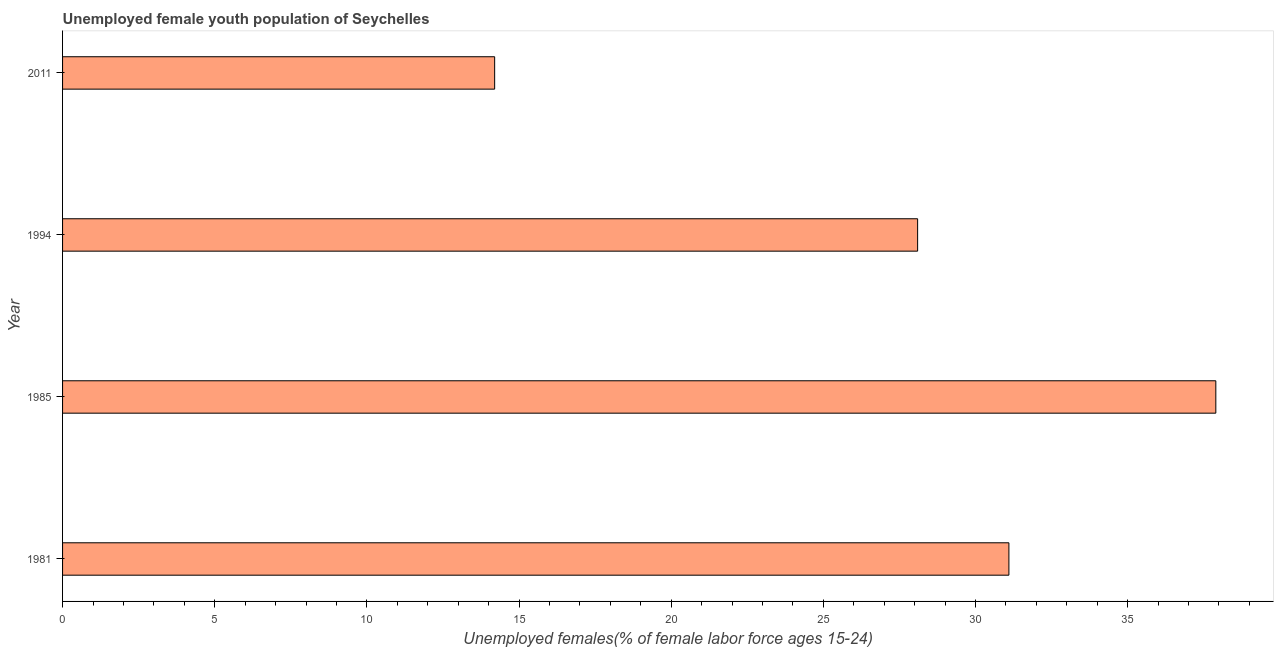Does the graph contain grids?
Offer a terse response. No. What is the title of the graph?
Make the answer very short. Unemployed female youth population of Seychelles. What is the label or title of the X-axis?
Offer a terse response. Unemployed females(% of female labor force ages 15-24). What is the label or title of the Y-axis?
Provide a succinct answer. Year. What is the unemployed female youth in 1985?
Give a very brief answer. 37.9. Across all years, what is the maximum unemployed female youth?
Make the answer very short. 37.9. Across all years, what is the minimum unemployed female youth?
Keep it short and to the point. 14.2. In which year was the unemployed female youth maximum?
Your answer should be compact. 1985. What is the sum of the unemployed female youth?
Your answer should be compact. 111.3. What is the difference between the unemployed female youth in 1994 and 2011?
Keep it short and to the point. 13.9. What is the average unemployed female youth per year?
Provide a succinct answer. 27.82. What is the median unemployed female youth?
Ensure brevity in your answer.  29.6. In how many years, is the unemployed female youth greater than 30 %?
Offer a very short reply. 2. Do a majority of the years between 1985 and 2011 (inclusive) have unemployed female youth greater than 24 %?
Ensure brevity in your answer.  Yes. What is the ratio of the unemployed female youth in 1985 to that in 2011?
Offer a very short reply. 2.67. Is the sum of the unemployed female youth in 1994 and 2011 greater than the maximum unemployed female youth across all years?
Provide a short and direct response. Yes. What is the difference between the highest and the lowest unemployed female youth?
Ensure brevity in your answer.  23.7. How many bars are there?
Give a very brief answer. 4. How many years are there in the graph?
Make the answer very short. 4. What is the difference between two consecutive major ticks on the X-axis?
Offer a terse response. 5. Are the values on the major ticks of X-axis written in scientific E-notation?
Offer a very short reply. No. What is the Unemployed females(% of female labor force ages 15-24) of 1981?
Offer a terse response. 31.1. What is the Unemployed females(% of female labor force ages 15-24) of 1985?
Provide a short and direct response. 37.9. What is the Unemployed females(% of female labor force ages 15-24) in 1994?
Offer a terse response. 28.1. What is the Unemployed females(% of female labor force ages 15-24) in 2011?
Provide a succinct answer. 14.2. What is the difference between the Unemployed females(% of female labor force ages 15-24) in 1985 and 2011?
Ensure brevity in your answer.  23.7. What is the ratio of the Unemployed females(% of female labor force ages 15-24) in 1981 to that in 1985?
Keep it short and to the point. 0.82. What is the ratio of the Unemployed females(% of female labor force ages 15-24) in 1981 to that in 1994?
Offer a very short reply. 1.11. What is the ratio of the Unemployed females(% of female labor force ages 15-24) in 1981 to that in 2011?
Offer a terse response. 2.19. What is the ratio of the Unemployed females(% of female labor force ages 15-24) in 1985 to that in 1994?
Give a very brief answer. 1.35. What is the ratio of the Unemployed females(% of female labor force ages 15-24) in 1985 to that in 2011?
Provide a succinct answer. 2.67. What is the ratio of the Unemployed females(% of female labor force ages 15-24) in 1994 to that in 2011?
Your answer should be very brief. 1.98. 